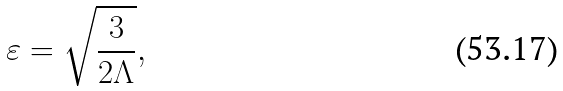Convert formula to latex. <formula><loc_0><loc_0><loc_500><loc_500>\varepsilon = \sqrt { \frac { 3 } { 2 \Lambda } } ,</formula> 